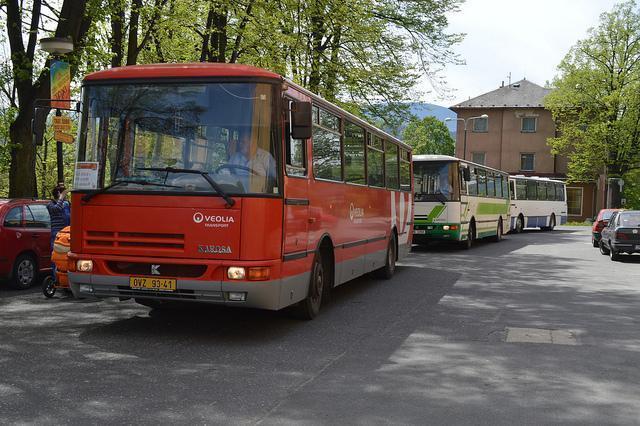Why are the buses lined up?
Select the correct answer and articulate reasoning with the following format: 'Answer: answer
Rationale: rationale.'
Options: Awaiting passengers, racing, heavy traffic, are lost. Answer: awaiting passengers.
Rationale: They carry people to different locations 